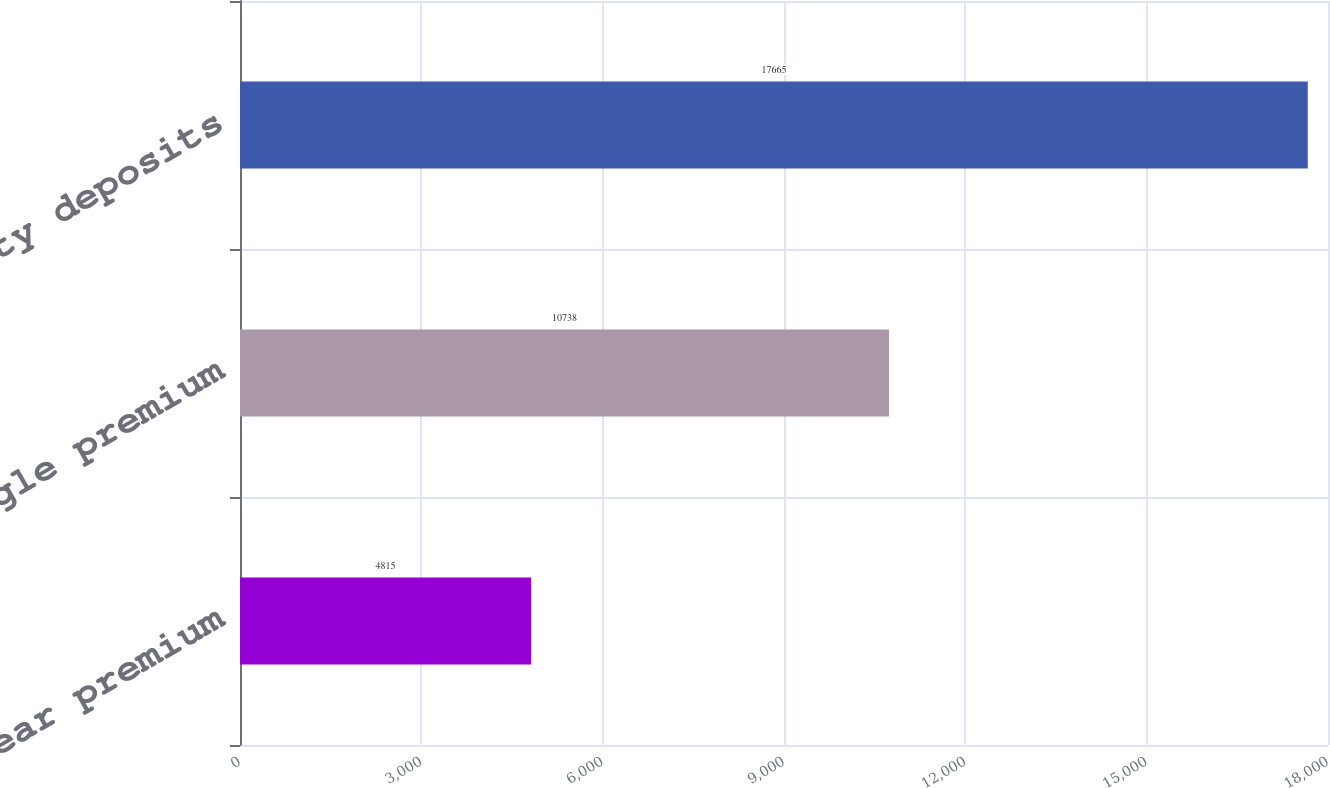Convert chart. <chart><loc_0><loc_0><loc_500><loc_500><bar_chart><fcel>First year premium<fcel>Single premium<fcel>Annuity deposits<nl><fcel>4815<fcel>10738<fcel>17665<nl></chart> 